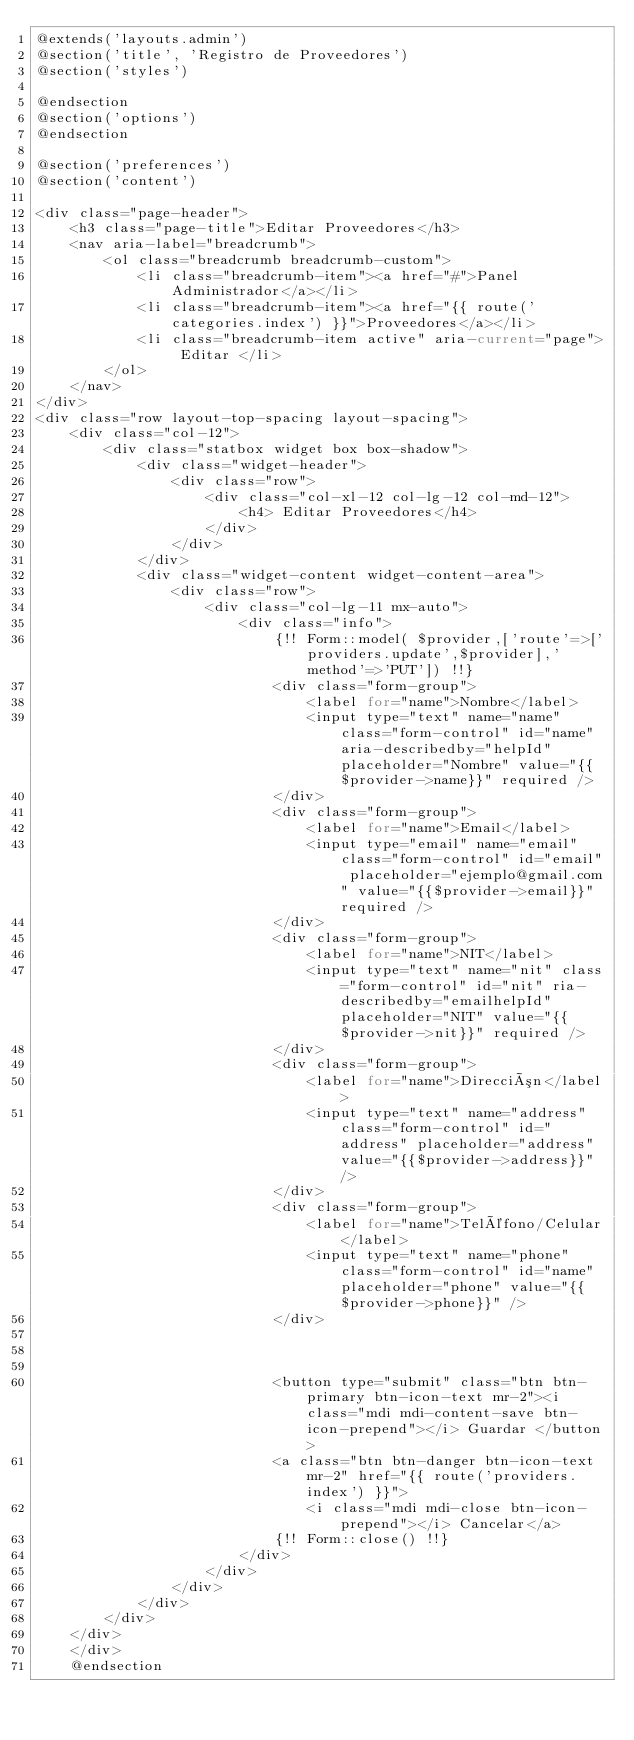<code> <loc_0><loc_0><loc_500><loc_500><_PHP_>@extends('layouts.admin')
@section('title', 'Registro de Proveedores')
@section('styles')

@endsection
@section('options')
@endsection

@section('preferences')
@section('content')

<div class="page-header">
    <h3 class="page-title">Editar Proveedores</h3>
    <nav aria-label="breadcrumb">
        <ol class="breadcrumb breadcrumb-custom">
            <li class="breadcrumb-item"><a href="#">Panel Administrador</a></li>
            <li class="breadcrumb-item"><a href="{{ route('categories.index') }}">Proveedores</a></li>
            <li class="breadcrumb-item active" aria-current="page"> Editar </li>
        </ol>
    </nav>
</div>
<div class="row layout-top-spacing layout-spacing">
    <div class="col-12">
        <div class="statbox widget box box-shadow">
            <div class="widget-header">
                <div class="row">
                    <div class="col-xl-12 col-lg-12 col-md-12">
                        <h4> Editar Proveedores</h4>
                    </div>
                </div>
            </div>
            <div class="widget-content widget-content-area">
                <div class="row">
                    <div class="col-lg-11 mx-auto">
                        <div class="info">
                            {!! Form::model( $provider,['route'=>['providers.update',$provider],'method'=>'PUT']) !!}
                            <div class="form-group">
                                <label for="name">Nombre</label>
                                <input type="text" name="name" class="form-control" id="name" aria-describedby="helpId" placeholder="Nombre" value="{{$provider->name}}" required />
                            </div>
                            <div class="form-group">
                                <label for="name">Email</label>
                                <input type="email" name="email" class="form-control" id="email" placeholder="ejemplo@gmail.com" value="{{$provider->email}}" required />
                            </div>
                            <div class="form-group">
                                <label for="name">NIT</label>
                                <input type="text" name="nit" class="form-control" id="nit" ria-describedby="emailhelpId" placeholder="NIT" value="{{$provider->nit}}" required />
                            </div>
                            <div class="form-group">
                                <label for="name">Dirección</label>
                                <input type="text" name="address" class="form-control" id="address" placeholder="address" value="{{$provider->address}}" />
                            </div>
                            <div class="form-group">
                                <label for="name">Teléfono/Celular</label>
                                <input type="text" name="phone" class="form-control" id="name" placeholder="phone" value="{{$provider->phone}}" />
                            </div>



                            <button type="submit" class="btn btn-primary btn-icon-text mr-2"><i class="mdi mdi-content-save btn-icon-prepend"></i> Guardar </button>
                            <a class="btn btn-danger btn-icon-text mr-2" href="{{ route('providers.index') }}">
                                <i class="mdi mdi-close btn-icon-prepend"></i> Cancelar</a>
                            {!! Form::close() !!}
                        </div>
                    </div>
                </div>
            </div>
        </div>
    </div>
    </div>
    @endsection
</code> 